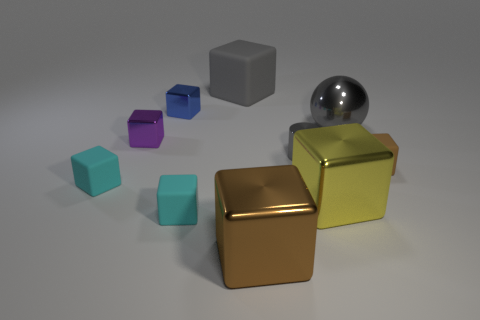Subtract all tiny shiny blocks. How many blocks are left? 6 Subtract all balls. How many objects are left? 9 Subtract all cyan blocks. How many blocks are left? 6 Subtract all green cylinders. How many purple cubes are left? 1 Add 6 large gray matte blocks. How many large gray matte blocks are left? 7 Add 1 rubber spheres. How many rubber spheres exist? 1 Subtract 1 gray spheres. How many objects are left? 9 Subtract 1 cubes. How many cubes are left? 7 Subtract all red balls. Subtract all purple blocks. How many balls are left? 1 Subtract all small blue objects. Subtract all large green rubber spheres. How many objects are left? 9 